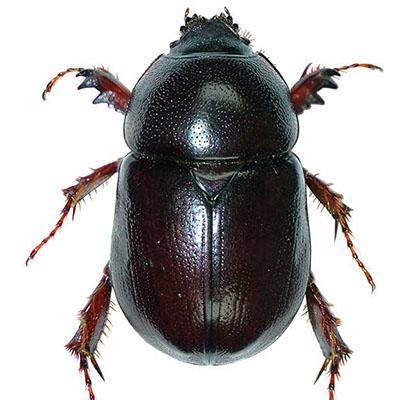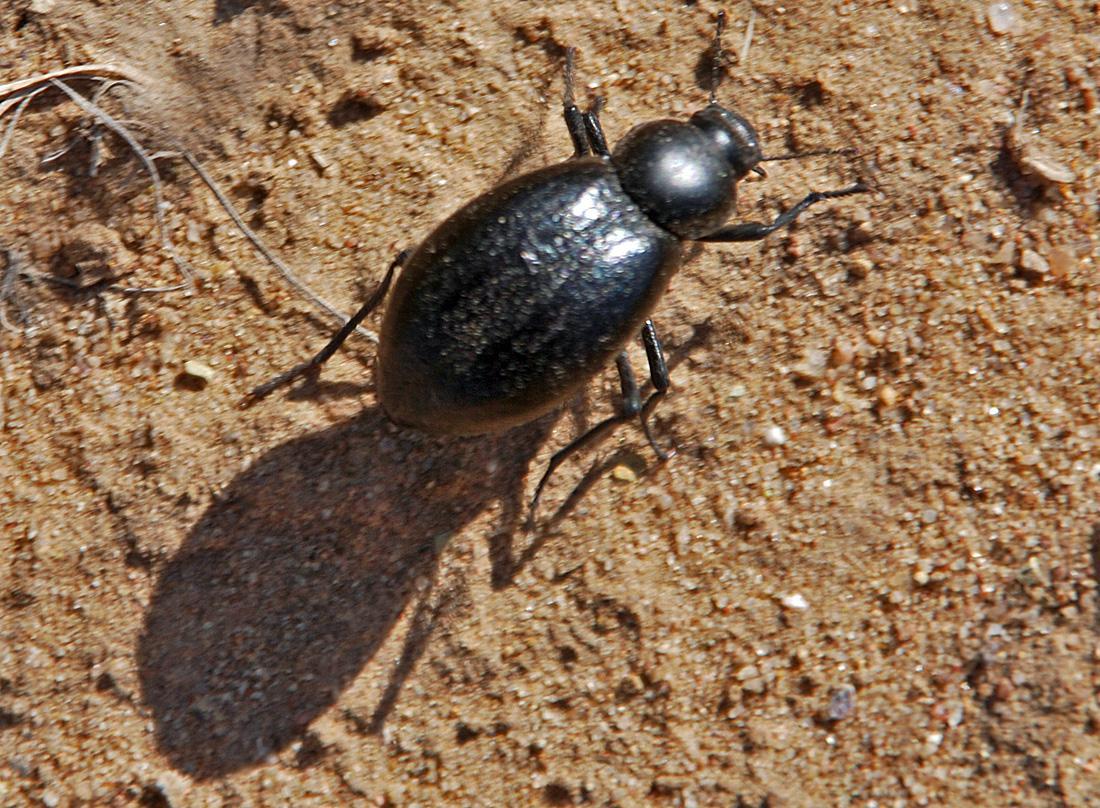The first image is the image on the left, the second image is the image on the right. For the images shown, is this caption "There are two black beetles in total." true? Answer yes or no. Yes. 